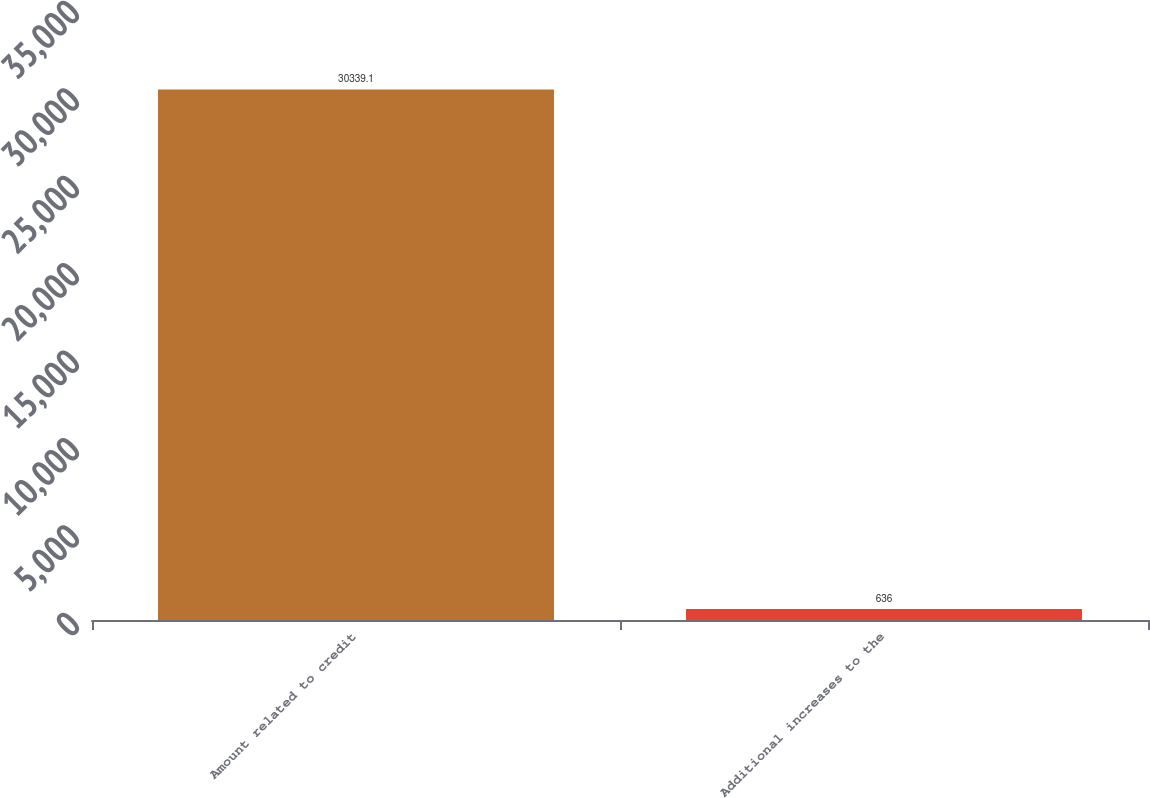<chart> <loc_0><loc_0><loc_500><loc_500><bar_chart><fcel>Amount related to credit<fcel>Additional increases to the<nl><fcel>30339.1<fcel>636<nl></chart> 